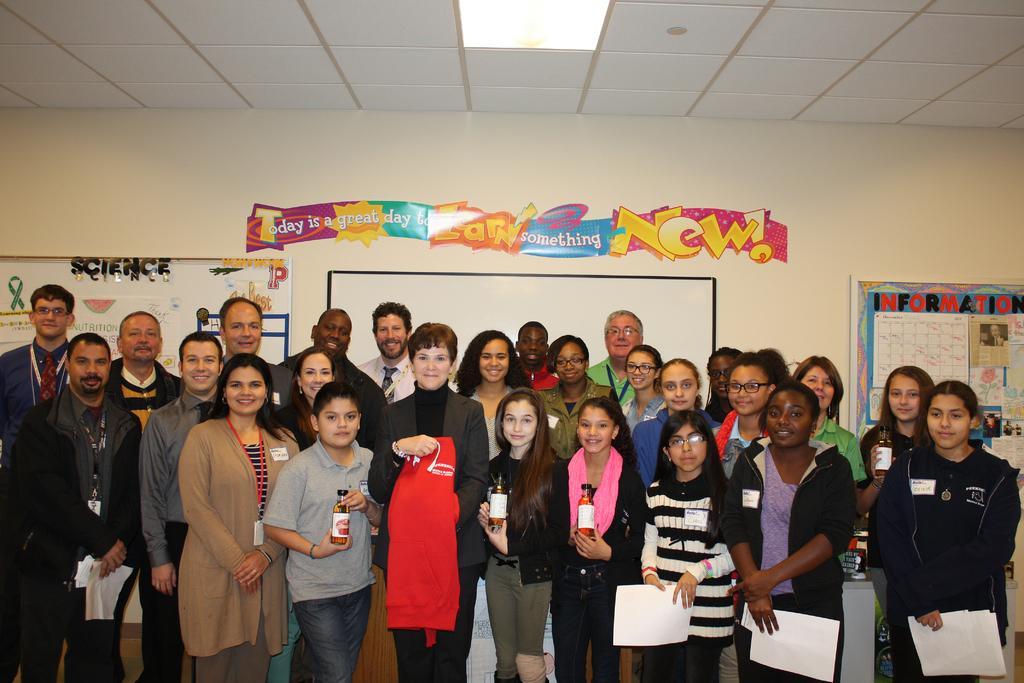Please provide a concise description of this image. There are many people standing. Some are holding papers and some are holding bottles. In the back there is a wall with screen, notice board with something on that. Also there is another board with something on that. On the ceiling there is light. Also there is a decoration on the wall. 